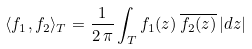Convert formula to latex. <formula><loc_0><loc_0><loc_500><loc_500>\langle f _ { 1 } , f _ { 2 } \rangle _ { T } = \frac { 1 } { 2 \, \pi } \int _ { T } f _ { 1 } ( z ) \, \overline { f _ { 2 } ( z ) } \, | d z |</formula> 